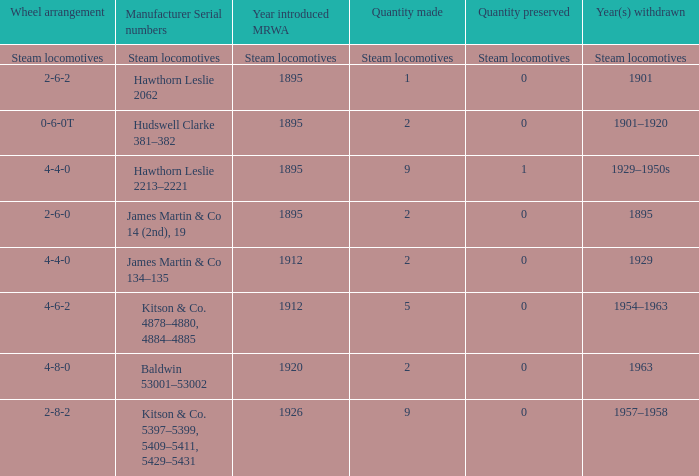What was the year the MRWA with a wheel arrangement of 4-6-2 was introduced? 1912.0. 